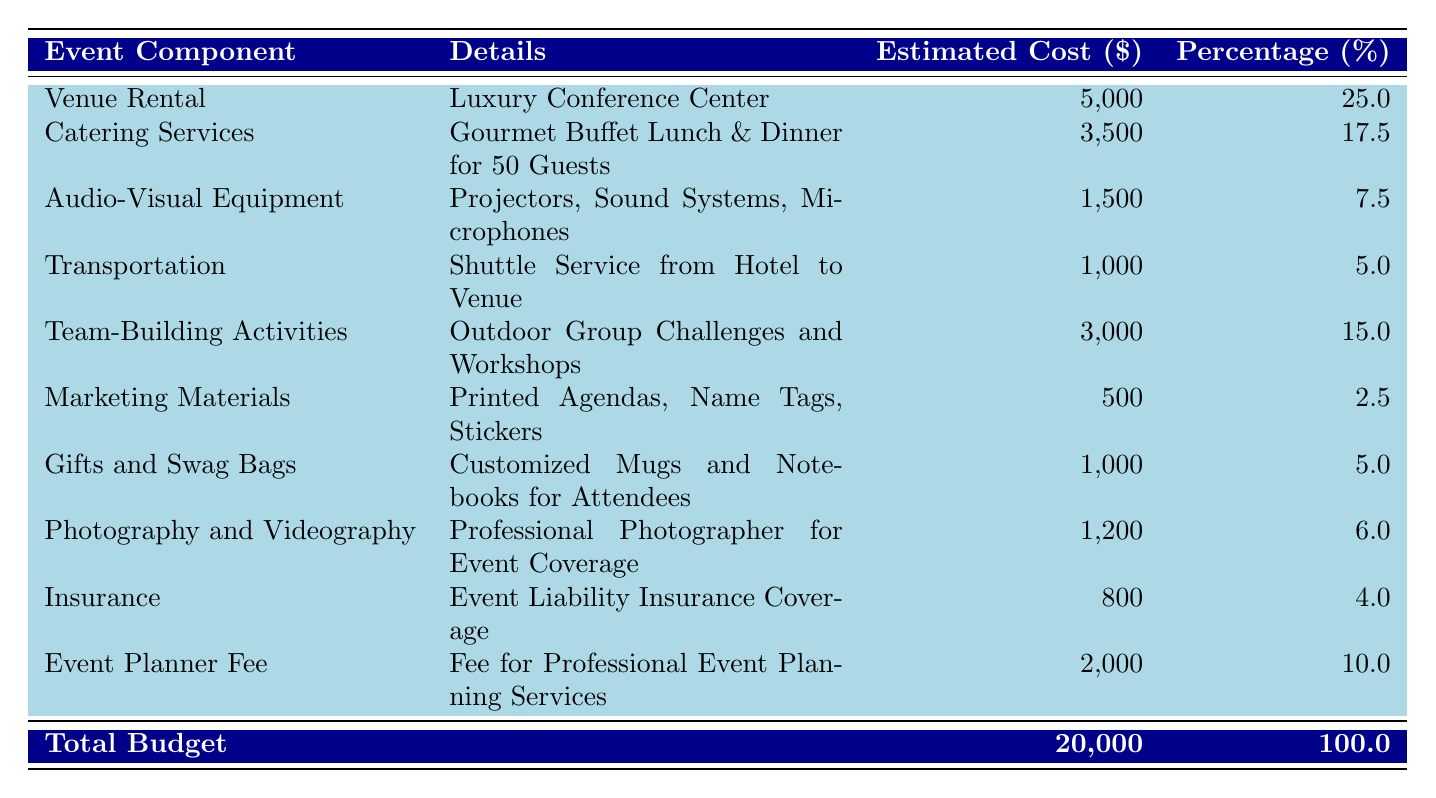What is the estimated cost for catering services? The table lists the estimated cost for catering services as $3,500.
Answer: $3,500 What percentage of the total budget is allocated to venue rental? The table indicates that venue rental is allocated 25% of the total budget.
Answer: 25% What is the total estimated cost of gifts and swag bags? According to the table, gifts and swag bags have an estimated cost of $1,000.
Answer: $1,000 Is the budget for transportation more than the budget for marketing materials? The transportation budget is $1,000, and the marketing materials budget is $500; $1,000 is greater than $500.
Answer: Yes What is the total estimated cost for team-building activities and catering services combined? The team-building activities cost $3,000, and catering services cost $3,500; their combined cost is $3,000 + $3,500 = $6,500.
Answer: $6,500 How much of the total budget is spent on audio-visual equipment compared to insurance? Audio-visual equipment costs $1,500, and insurance costs $800; the difference is $1,500 - $800 = $700.
Answer: $700 What is the average estimated cost of all event components? The sum of all estimated costs is $20,000 and there are 10 components; the average cost is $20,000 / 10 = $2,000.
Answer: $2,000 Which event component has the highest percentage of the total budget? The table indicates that venue rental has the highest percentage at 25%.
Answer: Venue Rental If we exclude marketing materials, what percentage of the remaining budget is spent on gifts and swag bags? The total budget minus marketing materials is $20,000 - $500 = $19,500. Gifts and swag bags cost $1,000; their percentage of the remaining budget is ($1,000/$19,500) * 100 ≈ 5.13%.
Answer: Approximately 5.13% What is the total cost for photography and videography along with the event planner fee? Photography and videography costs $1,200, while the event planner fee is $2,000; their total is $1,200 + $2,000 = $3,200.
Answer: $3,200 